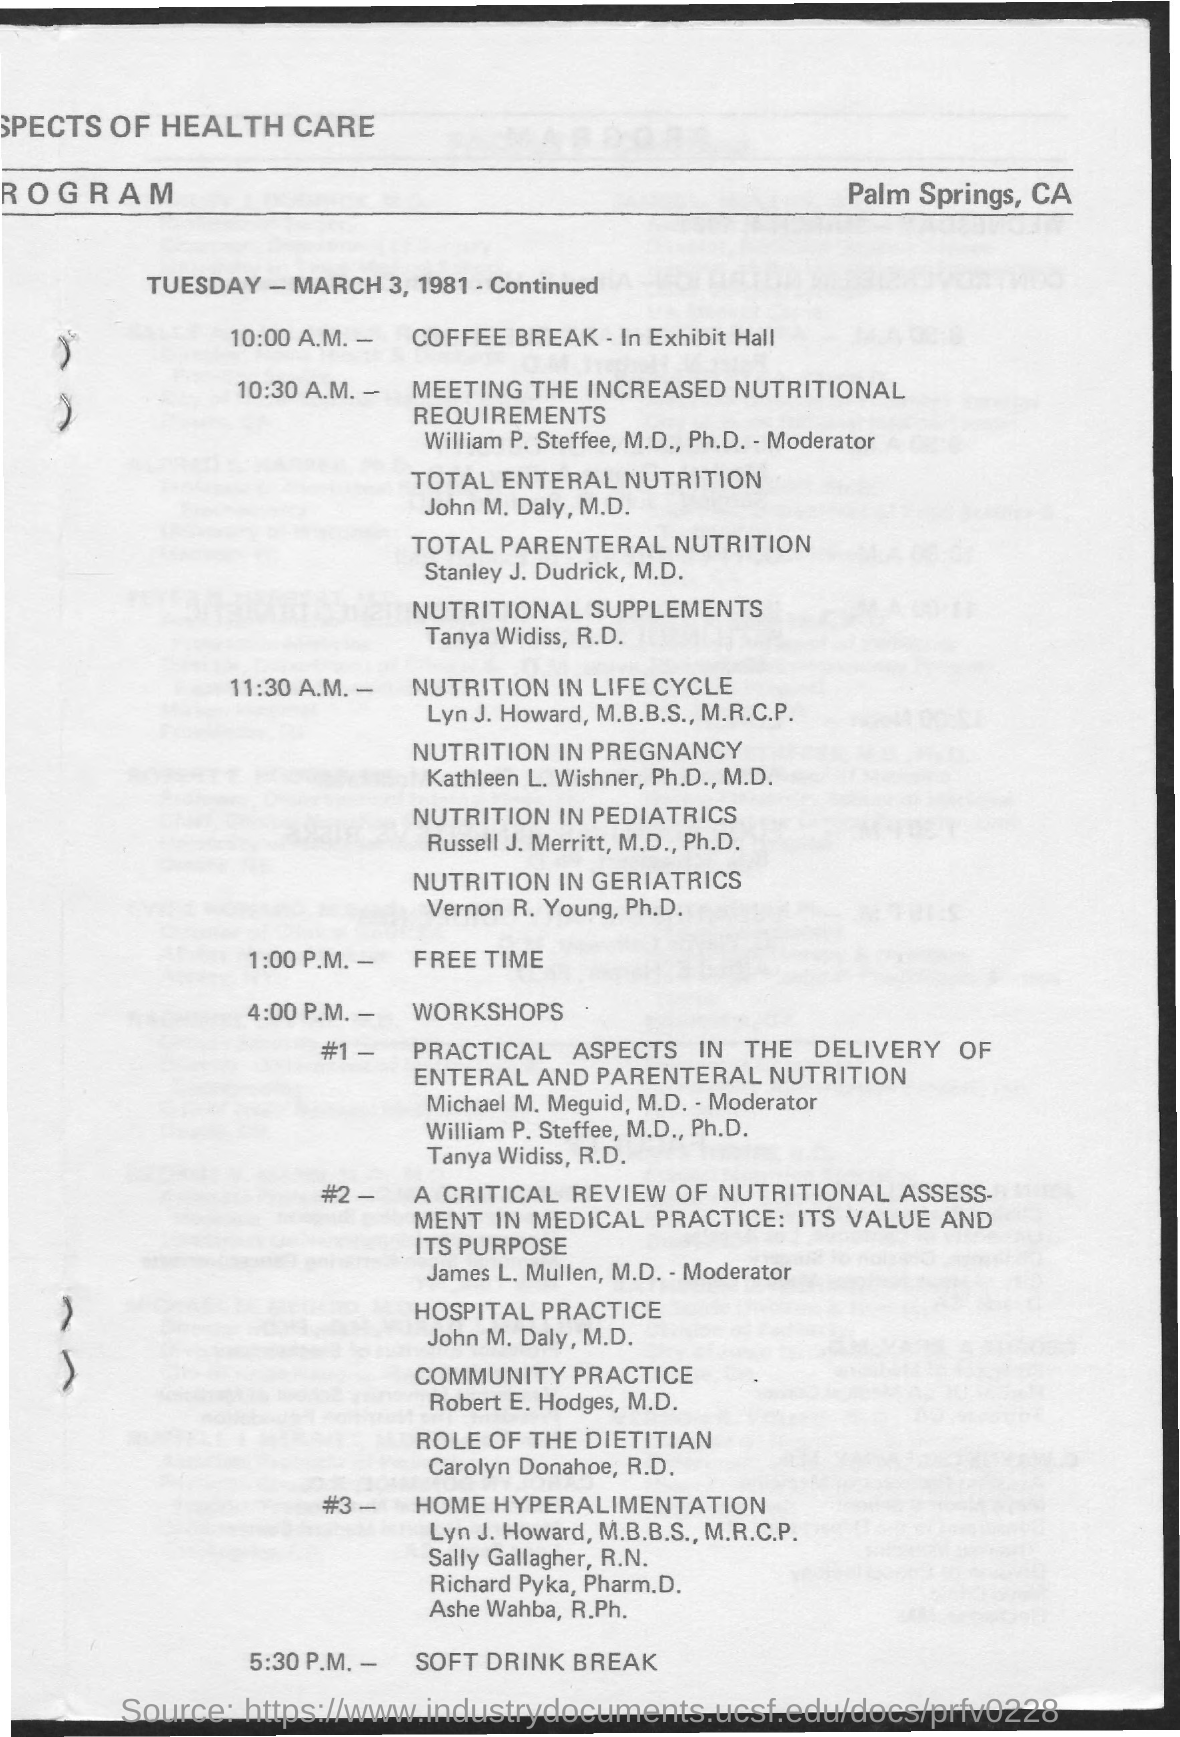When is COFFEE BREAK on TUESDAY?
Ensure brevity in your answer.  10:00 A.M. When is "NUTRITION IN LIFE CYCLE"?
Offer a very short reply. 11:30 a.m. When is "FREE TIME" as mentioned?
Give a very brief answer. 1:00 P.M. When is "SOFT DRINK BREAK"?
Offer a very short reply. 5:30 p.m. "#1" WORKSHOP is on which topic?
Give a very brief answer. Practical aspects in the delivery of enteral and parenteral nutrition. "#3" WORKSHOP is on which topic?
Offer a terse response. HOME HYPERALIMENTATION. 